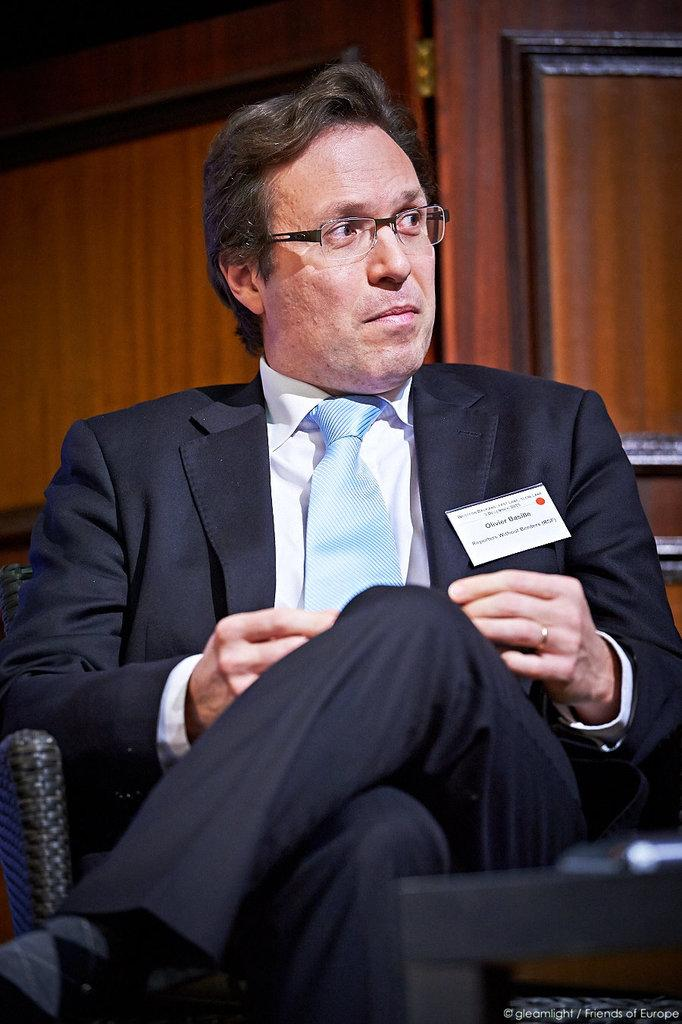Who is present in the image? There is a man in the image. What is the man doing in the image? The man is sitting. What is the man wearing in the image? The man is wearing a suit. What can be seen in the background of the image? There is a door visible in the image. What is the print on the back of the man's suit in the image? There is no information about the print on the back of the man's suit in the image, as the facts provided do not mention any specific details about the suit's design. 